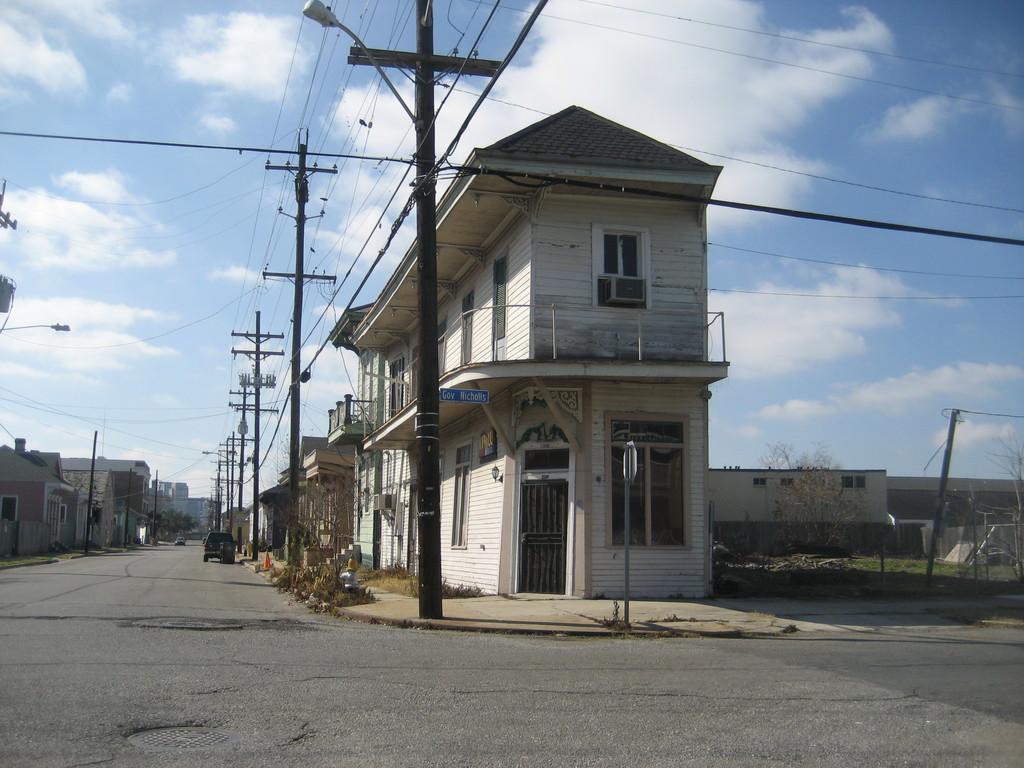How would you summarize this image in a sentence or two? There is a vehicle on the road. Here we can see poles, wires, trees, plants, and houses. In the background there is sky with clouds. 